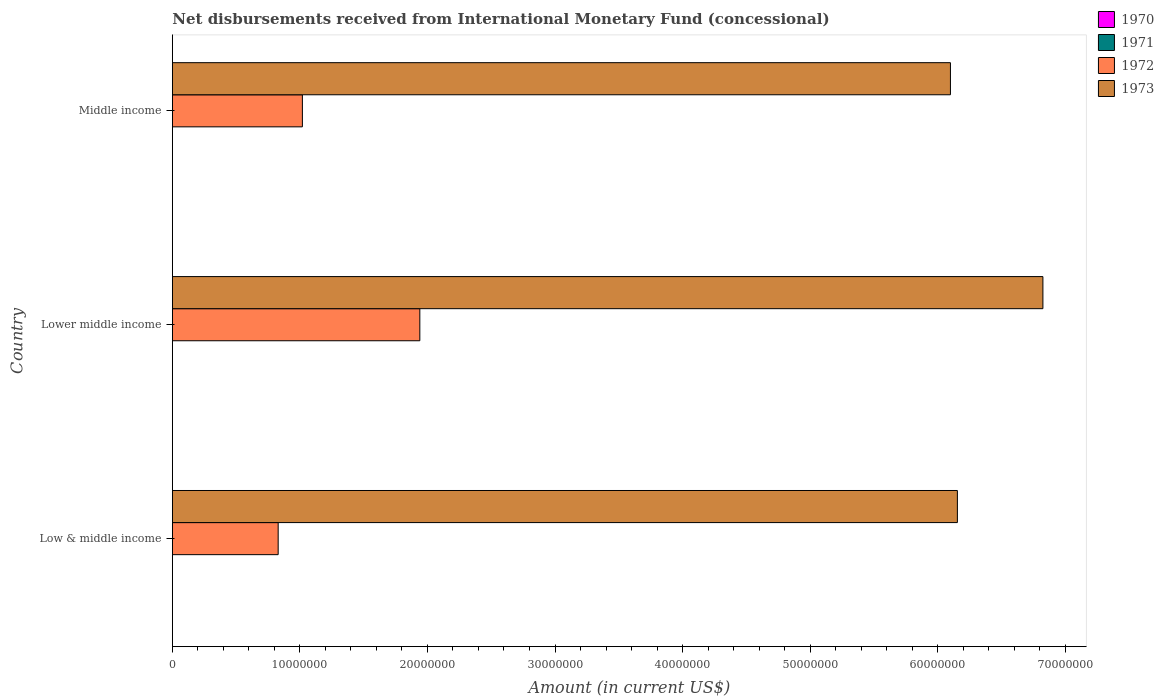How many bars are there on the 3rd tick from the top?
Provide a short and direct response. 2. What is the label of the 2nd group of bars from the top?
Offer a very short reply. Lower middle income. In how many cases, is the number of bars for a given country not equal to the number of legend labels?
Ensure brevity in your answer.  3. What is the amount of disbursements received from International Monetary Fund in 1972 in Lower middle income?
Provide a short and direct response. 1.94e+07. Across all countries, what is the maximum amount of disbursements received from International Monetary Fund in 1973?
Give a very brief answer. 6.83e+07. Across all countries, what is the minimum amount of disbursements received from International Monetary Fund in 1972?
Make the answer very short. 8.30e+06. In which country was the amount of disbursements received from International Monetary Fund in 1973 maximum?
Give a very brief answer. Lower middle income. What is the total amount of disbursements received from International Monetary Fund in 1972 in the graph?
Ensure brevity in your answer.  3.79e+07. What is the difference between the amount of disbursements received from International Monetary Fund in 1973 in Low & middle income and that in Lower middle income?
Your response must be concise. -6.70e+06. What is the difference between the amount of disbursements received from International Monetary Fund in 1971 in Lower middle income and the amount of disbursements received from International Monetary Fund in 1973 in Middle income?
Make the answer very short. -6.10e+07. In how many countries, is the amount of disbursements received from International Monetary Fund in 1970 greater than 32000000 US$?
Offer a terse response. 0. What is the ratio of the amount of disbursements received from International Monetary Fund in 1972 in Lower middle income to that in Middle income?
Offer a terse response. 1.9. What is the difference between the highest and the second highest amount of disbursements received from International Monetary Fund in 1973?
Offer a terse response. 6.70e+06. What is the difference between the highest and the lowest amount of disbursements received from International Monetary Fund in 1972?
Provide a short and direct response. 1.11e+07. In how many countries, is the amount of disbursements received from International Monetary Fund in 1970 greater than the average amount of disbursements received from International Monetary Fund in 1970 taken over all countries?
Provide a short and direct response. 0. Is the sum of the amount of disbursements received from International Monetary Fund in 1973 in Lower middle income and Middle income greater than the maximum amount of disbursements received from International Monetary Fund in 1971 across all countries?
Offer a terse response. Yes. Is it the case that in every country, the sum of the amount of disbursements received from International Monetary Fund in 1972 and amount of disbursements received from International Monetary Fund in 1970 is greater than the sum of amount of disbursements received from International Monetary Fund in 1971 and amount of disbursements received from International Monetary Fund in 1973?
Give a very brief answer. No. Is it the case that in every country, the sum of the amount of disbursements received from International Monetary Fund in 1971 and amount of disbursements received from International Monetary Fund in 1973 is greater than the amount of disbursements received from International Monetary Fund in 1970?
Your answer should be very brief. Yes. How many bars are there?
Provide a succinct answer. 6. How many countries are there in the graph?
Make the answer very short. 3. Where does the legend appear in the graph?
Your answer should be compact. Top right. How many legend labels are there?
Offer a terse response. 4. How are the legend labels stacked?
Offer a very short reply. Vertical. What is the title of the graph?
Your response must be concise. Net disbursements received from International Monetary Fund (concessional). What is the label or title of the X-axis?
Keep it short and to the point. Amount (in current US$). What is the Amount (in current US$) of 1971 in Low & middle income?
Provide a succinct answer. 0. What is the Amount (in current US$) of 1972 in Low & middle income?
Your response must be concise. 8.30e+06. What is the Amount (in current US$) of 1973 in Low & middle income?
Offer a very short reply. 6.16e+07. What is the Amount (in current US$) of 1970 in Lower middle income?
Keep it short and to the point. 0. What is the Amount (in current US$) in 1972 in Lower middle income?
Keep it short and to the point. 1.94e+07. What is the Amount (in current US$) in 1973 in Lower middle income?
Provide a succinct answer. 6.83e+07. What is the Amount (in current US$) in 1971 in Middle income?
Offer a terse response. 0. What is the Amount (in current US$) of 1972 in Middle income?
Give a very brief answer. 1.02e+07. What is the Amount (in current US$) in 1973 in Middle income?
Make the answer very short. 6.10e+07. Across all countries, what is the maximum Amount (in current US$) of 1972?
Your answer should be very brief. 1.94e+07. Across all countries, what is the maximum Amount (in current US$) of 1973?
Provide a short and direct response. 6.83e+07. Across all countries, what is the minimum Amount (in current US$) of 1972?
Keep it short and to the point. 8.30e+06. Across all countries, what is the minimum Amount (in current US$) of 1973?
Provide a succinct answer. 6.10e+07. What is the total Amount (in current US$) of 1971 in the graph?
Your answer should be compact. 0. What is the total Amount (in current US$) in 1972 in the graph?
Provide a short and direct response. 3.79e+07. What is the total Amount (in current US$) of 1973 in the graph?
Keep it short and to the point. 1.91e+08. What is the difference between the Amount (in current US$) in 1972 in Low & middle income and that in Lower middle income?
Make the answer very short. -1.11e+07. What is the difference between the Amount (in current US$) in 1973 in Low & middle income and that in Lower middle income?
Offer a terse response. -6.70e+06. What is the difference between the Amount (in current US$) in 1972 in Low & middle income and that in Middle income?
Give a very brief answer. -1.90e+06. What is the difference between the Amount (in current US$) of 1973 in Low & middle income and that in Middle income?
Your answer should be very brief. 5.46e+05. What is the difference between the Amount (in current US$) of 1972 in Lower middle income and that in Middle income?
Offer a terse response. 9.21e+06. What is the difference between the Amount (in current US$) of 1973 in Lower middle income and that in Middle income?
Your response must be concise. 7.25e+06. What is the difference between the Amount (in current US$) of 1972 in Low & middle income and the Amount (in current US$) of 1973 in Lower middle income?
Keep it short and to the point. -6.00e+07. What is the difference between the Amount (in current US$) in 1972 in Low & middle income and the Amount (in current US$) in 1973 in Middle income?
Ensure brevity in your answer.  -5.27e+07. What is the difference between the Amount (in current US$) of 1972 in Lower middle income and the Amount (in current US$) of 1973 in Middle income?
Offer a very short reply. -4.16e+07. What is the average Amount (in current US$) of 1972 per country?
Your answer should be very brief. 1.26e+07. What is the average Amount (in current US$) in 1973 per country?
Give a very brief answer. 6.36e+07. What is the difference between the Amount (in current US$) in 1972 and Amount (in current US$) in 1973 in Low & middle income?
Offer a terse response. -5.33e+07. What is the difference between the Amount (in current US$) in 1972 and Amount (in current US$) in 1973 in Lower middle income?
Give a very brief answer. -4.89e+07. What is the difference between the Amount (in current US$) in 1972 and Amount (in current US$) in 1973 in Middle income?
Your response must be concise. -5.08e+07. What is the ratio of the Amount (in current US$) in 1972 in Low & middle income to that in Lower middle income?
Ensure brevity in your answer.  0.43. What is the ratio of the Amount (in current US$) in 1973 in Low & middle income to that in Lower middle income?
Provide a short and direct response. 0.9. What is the ratio of the Amount (in current US$) in 1972 in Low & middle income to that in Middle income?
Your answer should be very brief. 0.81. What is the ratio of the Amount (in current US$) in 1972 in Lower middle income to that in Middle income?
Provide a succinct answer. 1.9. What is the ratio of the Amount (in current US$) in 1973 in Lower middle income to that in Middle income?
Ensure brevity in your answer.  1.12. What is the difference between the highest and the second highest Amount (in current US$) in 1972?
Your answer should be compact. 9.21e+06. What is the difference between the highest and the second highest Amount (in current US$) of 1973?
Give a very brief answer. 6.70e+06. What is the difference between the highest and the lowest Amount (in current US$) in 1972?
Give a very brief answer. 1.11e+07. What is the difference between the highest and the lowest Amount (in current US$) in 1973?
Provide a succinct answer. 7.25e+06. 